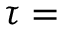<formula> <loc_0><loc_0><loc_500><loc_500>\tau =</formula> 